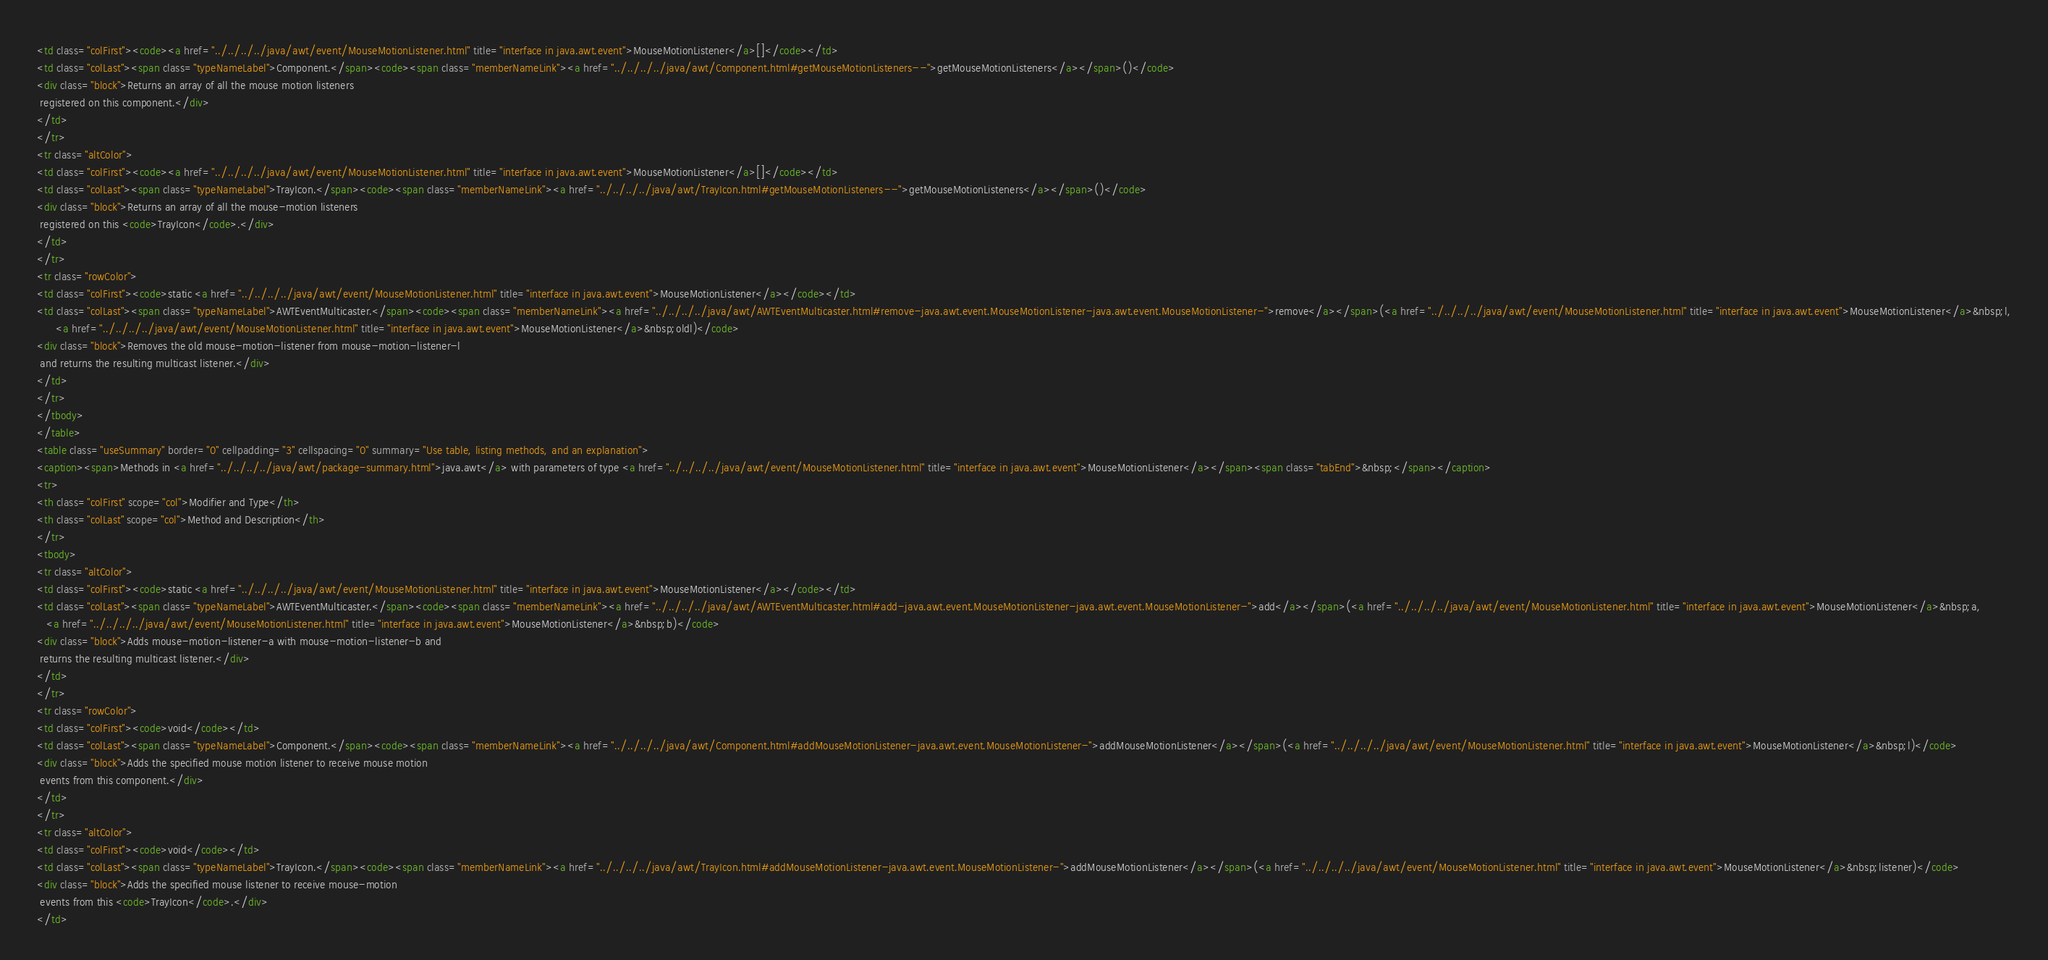Convert code to text. <code><loc_0><loc_0><loc_500><loc_500><_HTML_><td class="colFirst"><code><a href="../../../../java/awt/event/MouseMotionListener.html" title="interface in java.awt.event">MouseMotionListener</a>[]</code></td>
<td class="colLast"><span class="typeNameLabel">Component.</span><code><span class="memberNameLink"><a href="../../../../java/awt/Component.html#getMouseMotionListeners--">getMouseMotionListeners</a></span>()</code>
<div class="block">Returns an array of all the mouse motion listeners
 registered on this component.</div>
</td>
</tr>
<tr class="altColor">
<td class="colFirst"><code><a href="../../../../java/awt/event/MouseMotionListener.html" title="interface in java.awt.event">MouseMotionListener</a>[]</code></td>
<td class="colLast"><span class="typeNameLabel">TrayIcon.</span><code><span class="memberNameLink"><a href="../../../../java/awt/TrayIcon.html#getMouseMotionListeners--">getMouseMotionListeners</a></span>()</code>
<div class="block">Returns an array of all the mouse-motion listeners
 registered on this <code>TrayIcon</code>.</div>
</td>
</tr>
<tr class="rowColor">
<td class="colFirst"><code>static <a href="../../../../java/awt/event/MouseMotionListener.html" title="interface in java.awt.event">MouseMotionListener</a></code></td>
<td class="colLast"><span class="typeNameLabel">AWTEventMulticaster.</span><code><span class="memberNameLink"><a href="../../../../java/awt/AWTEventMulticaster.html#remove-java.awt.event.MouseMotionListener-java.awt.event.MouseMotionListener-">remove</a></span>(<a href="../../../../java/awt/event/MouseMotionListener.html" title="interface in java.awt.event">MouseMotionListener</a>&nbsp;l,
      <a href="../../../../java/awt/event/MouseMotionListener.html" title="interface in java.awt.event">MouseMotionListener</a>&nbsp;oldl)</code>
<div class="block">Removes the old mouse-motion-listener from mouse-motion-listener-l
 and returns the resulting multicast listener.</div>
</td>
</tr>
</tbody>
</table>
<table class="useSummary" border="0" cellpadding="3" cellspacing="0" summary="Use table, listing methods, and an explanation">
<caption><span>Methods in <a href="../../../../java/awt/package-summary.html">java.awt</a> with parameters of type <a href="../../../../java/awt/event/MouseMotionListener.html" title="interface in java.awt.event">MouseMotionListener</a></span><span class="tabEnd">&nbsp;</span></caption>
<tr>
<th class="colFirst" scope="col">Modifier and Type</th>
<th class="colLast" scope="col">Method and Description</th>
</tr>
<tbody>
<tr class="altColor">
<td class="colFirst"><code>static <a href="../../../../java/awt/event/MouseMotionListener.html" title="interface in java.awt.event">MouseMotionListener</a></code></td>
<td class="colLast"><span class="typeNameLabel">AWTEventMulticaster.</span><code><span class="memberNameLink"><a href="../../../../java/awt/AWTEventMulticaster.html#add-java.awt.event.MouseMotionListener-java.awt.event.MouseMotionListener-">add</a></span>(<a href="../../../../java/awt/event/MouseMotionListener.html" title="interface in java.awt.event">MouseMotionListener</a>&nbsp;a,
   <a href="../../../../java/awt/event/MouseMotionListener.html" title="interface in java.awt.event">MouseMotionListener</a>&nbsp;b)</code>
<div class="block">Adds mouse-motion-listener-a with mouse-motion-listener-b and
 returns the resulting multicast listener.</div>
</td>
</tr>
<tr class="rowColor">
<td class="colFirst"><code>void</code></td>
<td class="colLast"><span class="typeNameLabel">Component.</span><code><span class="memberNameLink"><a href="../../../../java/awt/Component.html#addMouseMotionListener-java.awt.event.MouseMotionListener-">addMouseMotionListener</a></span>(<a href="../../../../java/awt/event/MouseMotionListener.html" title="interface in java.awt.event">MouseMotionListener</a>&nbsp;l)</code>
<div class="block">Adds the specified mouse motion listener to receive mouse motion
 events from this component.</div>
</td>
</tr>
<tr class="altColor">
<td class="colFirst"><code>void</code></td>
<td class="colLast"><span class="typeNameLabel">TrayIcon.</span><code><span class="memberNameLink"><a href="../../../../java/awt/TrayIcon.html#addMouseMotionListener-java.awt.event.MouseMotionListener-">addMouseMotionListener</a></span>(<a href="../../../../java/awt/event/MouseMotionListener.html" title="interface in java.awt.event">MouseMotionListener</a>&nbsp;listener)</code>
<div class="block">Adds the specified mouse listener to receive mouse-motion
 events from this <code>TrayIcon</code>.</div>
</td></code> 